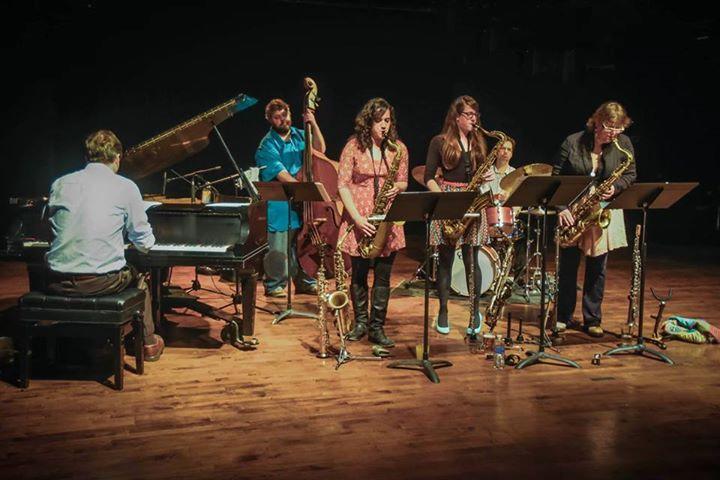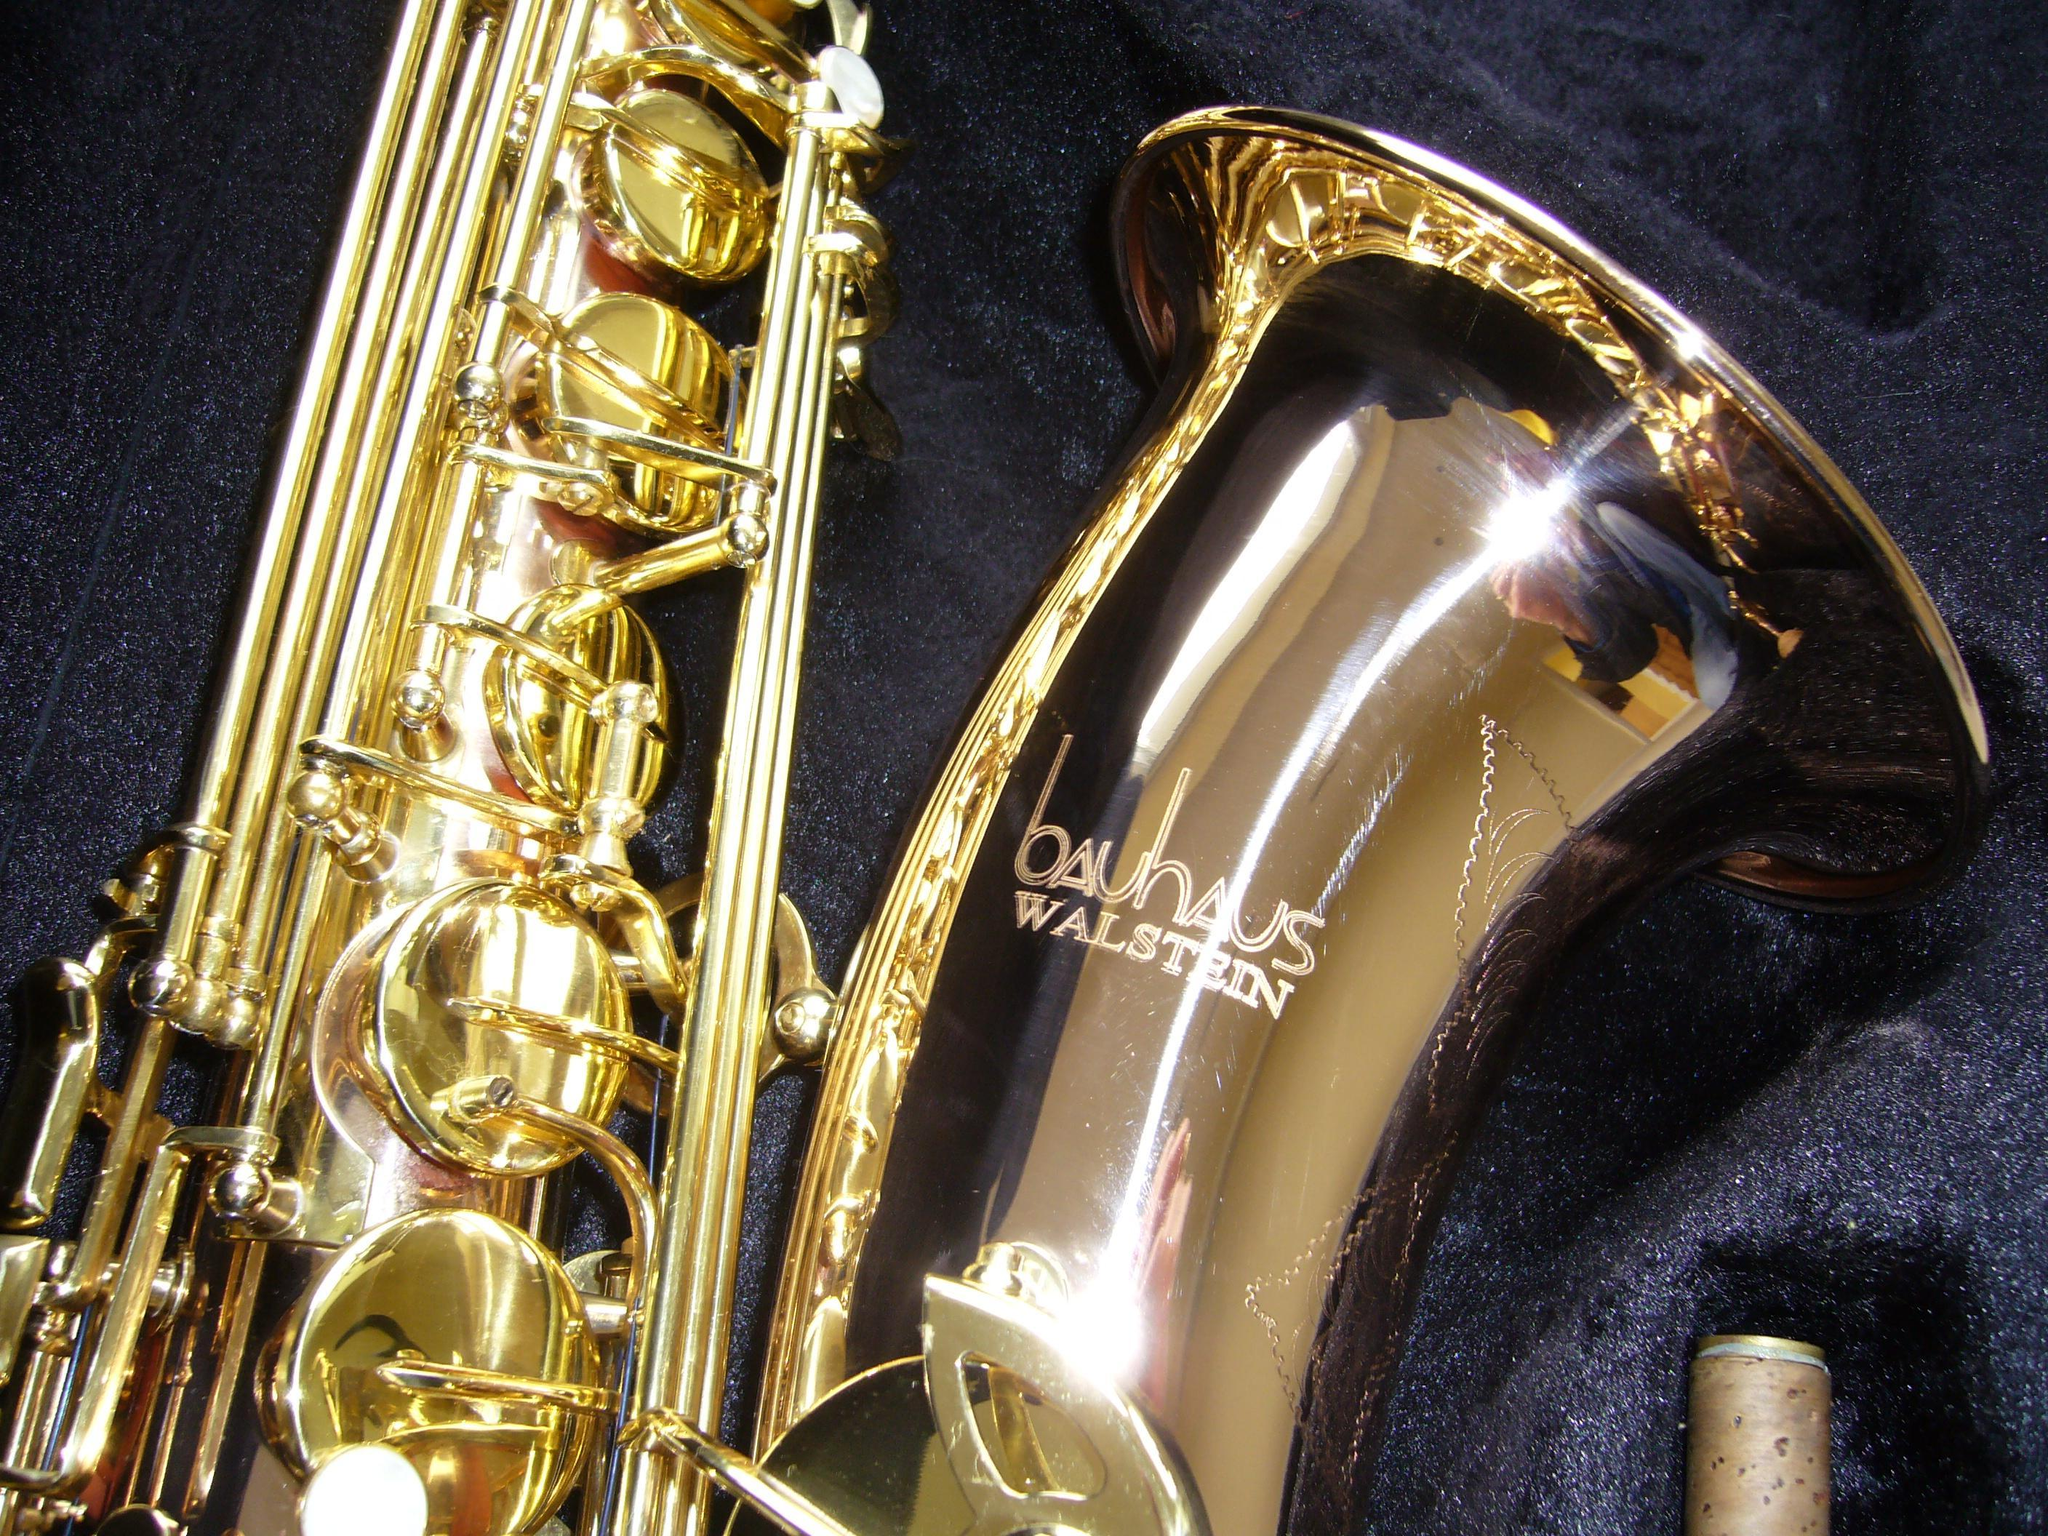The first image is the image on the left, the second image is the image on the right. Examine the images to the left and right. Is the description "The only instruments shown are woodwinds." accurate? Answer yes or no. No. 